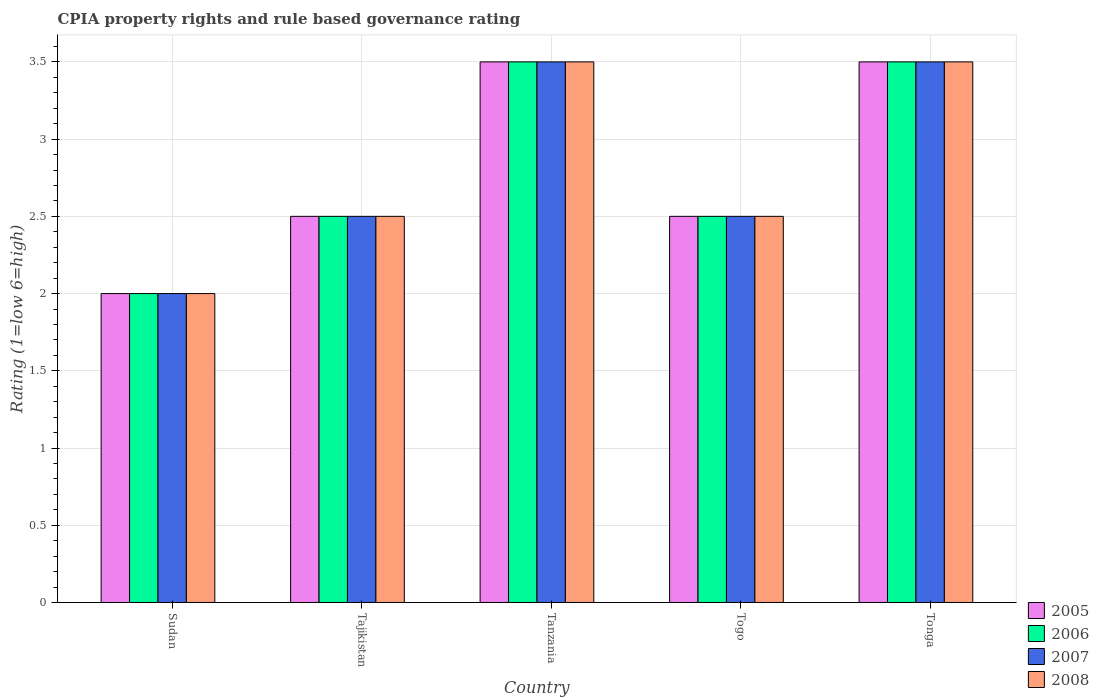Are the number of bars per tick equal to the number of legend labels?
Provide a short and direct response. Yes. Are the number of bars on each tick of the X-axis equal?
Ensure brevity in your answer.  Yes. How many bars are there on the 5th tick from the left?
Keep it short and to the point. 4. What is the label of the 5th group of bars from the left?
Your answer should be very brief. Tonga. Across all countries, what is the maximum CPIA rating in 2007?
Your answer should be very brief. 3.5. In which country was the CPIA rating in 2007 maximum?
Offer a terse response. Tanzania. In which country was the CPIA rating in 2008 minimum?
Provide a succinct answer. Sudan. What is the difference between the CPIA rating in 2006 in Togo and the CPIA rating in 2008 in Tanzania?
Your answer should be very brief. -1. What is the difference between the CPIA rating of/in 2007 and CPIA rating of/in 2008 in Tajikistan?
Provide a succinct answer. 0. In how many countries, is the CPIA rating in 2005 greater than 2.2?
Offer a terse response. 4. Is the CPIA rating in 2005 in Tajikistan less than that in Togo?
Your response must be concise. No. Is the difference between the CPIA rating in 2007 in Tanzania and Togo greater than the difference between the CPIA rating in 2008 in Tanzania and Togo?
Your answer should be very brief. No. What is the difference between the highest and the second highest CPIA rating in 2007?
Make the answer very short. -1. What is the difference between the highest and the lowest CPIA rating in 2007?
Your answer should be compact. 1.5. In how many countries, is the CPIA rating in 2007 greater than the average CPIA rating in 2007 taken over all countries?
Provide a short and direct response. 2. What does the 2nd bar from the left in Togo represents?
Make the answer very short. 2006. Is it the case that in every country, the sum of the CPIA rating in 2005 and CPIA rating in 2008 is greater than the CPIA rating in 2006?
Your answer should be very brief. Yes. How many bars are there?
Keep it short and to the point. 20. Are all the bars in the graph horizontal?
Your response must be concise. No. Are the values on the major ticks of Y-axis written in scientific E-notation?
Give a very brief answer. No. Does the graph contain any zero values?
Your answer should be compact. No. Does the graph contain grids?
Your answer should be compact. Yes. Where does the legend appear in the graph?
Your answer should be compact. Bottom right. How many legend labels are there?
Provide a succinct answer. 4. What is the title of the graph?
Your answer should be very brief. CPIA property rights and rule based governance rating. What is the label or title of the X-axis?
Your response must be concise. Country. What is the Rating (1=low 6=high) in 2008 in Sudan?
Provide a succinct answer. 2. What is the Rating (1=low 6=high) of 2005 in Tajikistan?
Offer a very short reply. 2.5. What is the Rating (1=low 6=high) of 2008 in Tajikistan?
Provide a short and direct response. 2.5. What is the Rating (1=low 6=high) in 2005 in Tanzania?
Your answer should be very brief. 3.5. What is the Rating (1=low 6=high) in 2006 in Tanzania?
Offer a terse response. 3.5. What is the Rating (1=low 6=high) in 2007 in Tanzania?
Offer a terse response. 3.5. What is the Rating (1=low 6=high) in 2008 in Tanzania?
Provide a succinct answer. 3.5. What is the Rating (1=low 6=high) in 2005 in Togo?
Your answer should be compact. 2.5. What is the Rating (1=low 6=high) in 2008 in Togo?
Your answer should be compact. 2.5. What is the Rating (1=low 6=high) in 2005 in Tonga?
Give a very brief answer. 3.5. What is the Rating (1=low 6=high) in 2006 in Tonga?
Make the answer very short. 3.5. What is the Rating (1=low 6=high) of 2007 in Tonga?
Give a very brief answer. 3.5. What is the Rating (1=low 6=high) in 2008 in Tonga?
Make the answer very short. 3.5. Across all countries, what is the maximum Rating (1=low 6=high) in 2006?
Make the answer very short. 3.5. Across all countries, what is the maximum Rating (1=low 6=high) of 2008?
Your answer should be very brief. 3.5. Across all countries, what is the minimum Rating (1=low 6=high) in 2006?
Provide a succinct answer. 2. Across all countries, what is the minimum Rating (1=low 6=high) in 2007?
Your answer should be very brief. 2. What is the total Rating (1=low 6=high) in 2007 in the graph?
Offer a very short reply. 14. What is the total Rating (1=low 6=high) in 2008 in the graph?
Provide a succinct answer. 14. What is the difference between the Rating (1=low 6=high) of 2005 in Sudan and that in Tajikistan?
Give a very brief answer. -0.5. What is the difference between the Rating (1=low 6=high) in 2007 in Sudan and that in Tajikistan?
Your response must be concise. -0.5. What is the difference between the Rating (1=low 6=high) of 2005 in Sudan and that in Tanzania?
Your answer should be compact. -1.5. What is the difference between the Rating (1=low 6=high) of 2007 in Sudan and that in Tanzania?
Provide a succinct answer. -1.5. What is the difference between the Rating (1=low 6=high) of 2008 in Sudan and that in Tanzania?
Provide a succinct answer. -1.5. What is the difference between the Rating (1=low 6=high) in 2005 in Sudan and that in Togo?
Offer a very short reply. -0.5. What is the difference between the Rating (1=low 6=high) in 2005 in Sudan and that in Tonga?
Keep it short and to the point. -1.5. What is the difference between the Rating (1=low 6=high) of 2006 in Sudan and that in Tonga?
Give a very brief answer. -1.5. What is the difference between the Rating (1=low 6=high) in 2007 in Sudan and that in Tonga?
Provide a succinct answer. -1.5. What is the difference between the Rating (1=low 6=high) in 2005 in Tajikistan and that in Tanzania?
Offer a terse response. -1. What is the difference between the Rating (1=low 6=high) of 2006 in Tajikistan and that in Tanzania?
Your response must be concise. -1. What is the difference between the Rating (1=low 6=high) in 2005 in Tajikistan and that in Togo?
Ensure brevity in your answer.  0. What is the difference between the Rating (1=low 6=high) of 2007 in Tajikistan and that in Togo?
Ensure brevity in your answer.  0. What is the difference between the Rating (1=low 6=high) of 2008 in Tajikistan and that in Togo?
Ensure brevity in your answer.  0. What is the difference between the Rating (1=low 6=high) of 2005 in Tajikistan and that in Tonga?
Offer a very short reply. -1. What is the difference between the Rating (1=low 6=high) of 2006 in Tajikistan and that in Tonga?
Offer a very short reply. -1. What is the difference between the Rating (1=low 6=high) of 2007 in Tajikistan and that in Tonga?
Offer a terse response. -1. What is the difference between the Rating (1=low 6=high) in 2008 in Tanzania and that in Togo?
Keep it short and to the point. 1. What is the difference between the Rating (1=low 6=high) in 2005 in Tanzania and that in Tonga?
Provide a short and direct response. 0. What is the difference between the Rating (1=low 6=high) in 2006 in Tanzania and that in Tonga?
Ensure brevity in your answer.  0. What is the difference between the Rating (1=low 6=high) of 2005 in Togo and that in Tonga?
Offer a very short reply. -1. What is the difference between the Rating (1=low 6=high) of 2008 in Togo and that in Tonga?
Ensure brevity in your answer.  -1. What is the difference between the Rating (1=low 6=high) of 2005 in Sudan and the Rating (1=low 6=high) of 2006 in Tajikistan?
Give a very brief answer. -0.5. What is the difference between the Rating (1=low 6=high) in 2005 in Sudan and the Rating (1=low 6=high) in 2007 in Tajikistan?
Your response must be concise. -0.5. What is the difference between the Rating (1=low 6=high) in 2005 in Sudan and the Rating (1=low 6=high) in 2008 in Tajikistan?
Make the answer very short. -0.5. What is the difference between the Rating (1=low 6=high) in 2006 in Sudan and the Rating (1=low 6=high) in 2007 in Tajikistan?
Your response must be concise. -0.5. What is the difference between the Rating (1=low 6=high) in 2005 in Sudan and the Rating (1=low 6=high) in 2007 in Tanzania?
Keep it short and to the point. -1.5. What is the difference between the Rating (1=low 6=high) in 2006 in Sudan and the Rating (1=low 6=high) in 2008 in Tanzania?
Provide a succinct answer. -1.5. What is the difference between the Rating (1=low 6=high) of 2007 in Sudan and the Rating (1=low 6=high) of 2008 in Tanzania?
Keep it short and to the point. -1.5. What is the difference between the Rating (1=low 6=high) of 2005 in Sudan and the Rating (1=low 6=high) of 2008 in Togo?
Provide a short and direct response. -0.5. What is the difference between the Rating (1=low 6=high) of 2006 in Sudan and the Rating (1=low 6=high) of 2007 in Togo?
Provide a succinct answer. -0.5. What is the difference between the Rating (1=low 6=high) in 2007 in Sudan and the Rating (1=low 6=high) in 2008 in Togo?
Your answer should be compact. -0.5. What is the difference between the Rating (1=low 6=high) of 2005 in Sudan and the Rating (1=low 6=high) of 2006 in Tonga?
Your answer should be compact. -1.5. What is the difference between the Rating (1=low 6=high) of 2005 in Sudan and the Rating (1=low 6=high) of 2007 in Tonga?
Offer a very short reply. -1.5. What is the difference between the Rating (1=low 6=high) in 2005 in Sudan and the Rating (1=low 6=high) in 2008 in Tonga?
Give a very brief answer. -1.5. What is the difference between the Rating (1=low 6=high) of 2006 in Sudan and the Rating (1=low 6=high) of 2008 in Tonga?
Provide a short and direct response. -1.5. What is the difference between the Rating (1=low 6=high) in 2007 in Sudan and the Rating (1=low 6=high) in 2008 in Tonga?
Your answer should be compact. -1.5. What is the difference between the Rating (1=low 6=high) in 2005 in Tajikistan and the Rating (1=low 6=high) in 2007 in Tanzania?
Offer a terse response. -1. What is the difference between the Rating (1=low 6=high) in 2006 in Tajikistan and the Rating (1=low 6=high) in 2008 in Tanzania?
Keep it short and to the point. -1. What is the difference between the Rating (1=low 6=high) of 2005 in Tajikistan and the Rating (1=low 6=high) of 2006 in Togo?
Offer a terse response. 0. What is the difference between the Rating (1=low 6=high) of 2005 in Tajikistan and the Rating (1=low 6=high) of 2007 in Togo?
Your answer should be very brief. 0. What is the difference between the Rating (1=low 6=high) of 2005 in Tajikistan and the Rating (1=low 6=high) of 2008 in Togo?
Provide a short and direct response. 0. What is the difference between the Rating (1=low 6=high) in 2006 in Tajikistan and the Rating (1=low 6=high) in 2008 in Togo?
Make the answer very short. 0. What is the difference between the Rating (1=low 6=high) of 2007 in Tajikistan and the Rating (1=low 6=high) of 2008 in Togo?
Offer a terse response. 0. What is the difference between the Rating (1=low 6=high) of 2005 in Tajikistan and the Rating (1=low 6=high) of 2006 in Tonga?
Ensure brevity in your answer.  -1. What is the difference between the Rating (1=low 6=high) of 2005 in Tajikistan and the Rating (1=low 6=high) of 2007 in Tonga?
Offer a terse response. -1. What is the difference between the Rating (1=low 6=high) in 2006 in Tajikistan and the Rating (1=low 6=high) in 2008 in Tonga?
Your answer should be very brief. -1. What is the difference between the Rating (1=low 6=high) in 2007 in Tajikistan and the Rating (1=low 6=high) in 2008 in Tonga?
Provide a short and direct response. -1. What is the difference between the Rating (1=low 6=high) in 2005 in Tanzania and the Rating (1=low 6=high) in 2007 in Togo?
Give a very brief answer. 1. What is the difference between the Rating (1=low 6=high) of 2005 in Tanzania and the Rating (1=low 6=high) of 2008 in Togo?
Make the answer very short. 1. What is the difference between the Rating (1=low 6=high) of 2007 in Tanzania and the Rating (1=low 6=high) of 2008 in Togo?
Offer a very short reply. 1. What is the difference between the Rating (1=low 6=high) of 2005 in Tanzania and the Rating (1=low 6=high) of 2006 in Tonga?
Offer a terse response. 0. What is the difference between the Rating (1=low 6=high) in 2005 in Tanzania and the Rating (1=low 6=high) in 2007 in Tonga?
Provide a succinct answer. 0. What is the difference between the Rating (1=low 6=high) of 2005 in Togo and the Rating (1=low 6=high) of 2008 in Tonga?
Make the answer very short. -1. What is the difference between the Rating (1=low 6=high) of 2006 in Togo and the Rating (1=low 6=high) of 2007 in Tonga?
Your answer should be compact. -1. What is the difference between the Rating (1=low 6=high) in 2006 in Togo and the Rating (1=low 6=high) in 2008 in Tonga?
Keep it short and to the point. -1. What is the average Rating (1=low 6=high) in 2005 per country?
Offer a terse response. 2.8. What is the average Rating (1=low 6=high) in 2006 per country?
Give a very brief answer. 2.8. What is the average Rating (1=low 6=high) of 2008 per country?
Offer a terse response. 2.8. What is the difference between the Rating (1=low 6=high) in 2005 and Rating (1=low 6=high) in 2006 in Sudan?
Offer a terse response. 0. What is the difference between the Rating (1=low 6=high) of 2005 and Rating (1=low 6=high) of 2007 in Sudan?
Make the answer very short. 0. What is the difference between the Rating (1=low 6=high) in 2005 and Rating (1=low 6=high) in 2008 in Sudan?
Ensure brevity in your answer.  0. What is the difference between the Rating (1=low 6=high) of 2006 and Rating (1=low 6=high) of 2007 in Sudan?
Provide a short and direct response. 0. What is the difference between the Rating (1=low 6=high) of 2007 and Rating (1=low 6=high) of 2008 in Sudan?
Provide a short and direct response. 0. What is the difference between the Rating (1=low 6=high) in 2005 and Rating (1=low 6=high) in 2007 in Tajikistan?
Your response must be concise. 0. What is the difference between the Rating (1=low 6=high) in 2006 and Rating (1=low 6=high) in 2007 in Tajikistan?
Make the answer very short. 0. What is the difference between the Rating (1=low 6=high) in 2006 and Rating (1=low 6=high) in 2008 in Tajikistan?
Make the answer very short. 0. What is the difference between the Rating (1=low 6=high) of 2005 and Rating (1=low 6=high) of 2006 in Tanzania?
Keep it short and to the point. 0. What is the difference between the Rating (1=low 6=high) in 2005 and Rating (1=low 6=high) in 2007 in Tanzania?
Your answer should be very brief. 0. What is the difference between the Rating (1=low 6=high) of 2005 and Rating (1=low 6=high) of 2008 in Tanzania?
Your response must be concise. 0. What is the difference between the Rating (1=low 6=high) of 2006 and Rating (1=low 6=high) of 2007 in Tanzania?
Offer a terse response. 0. What is the difference between the Rating (1=low 6=high) in 2007 and Rating (1=low 6=high) in 2008 in Tanzania?
Provide a short and direct response. 0. What is the difference between the Rating (1=low 6=high) of 2005 and Rating (1=low 6=high) of 2006 in Togo?
Your answer should be very brief. 0. What is the difference between the Rating (1=low 6=high) of 2006 and Rating (1=low 6=high) of 2007 in Togo?
Provide a succinct answer. 0. What is the difference between the Rating (1=low 6=high) in 2006 and Rating (1=low 6=high) in 2008 in Togo?
Provide a short and direct response. 0. What is the difference between the Rating (1=low 6=high) in 2007 and Rating (1=low 6=high) in 2008 in Togo?
Offer a terse response. 0. What is the difference between the Rating (1=low 6=high) in 2005 and Rating (1=low 6=high) in 2006 in Tonga?
Provide a short and direct response. 0. What is the difference between the Rating (1=low 6=high) in 2005 and Rating (1=low 6=high) in 2007 in Tonga?
Provide a short and direct response. 0. What is the difference between the Rating (1=low 6=high) of 2005 and Rating (1=low 6=high) of 2008 in Tonga?
Provide a succinct answer. 0. What is the difference between the Rating (1=low 6=high) in 2006 and Rating (1=low 6=high) in 2008 in Tonga?
Offer a very short reply. 0. What is the difference between the Rating (1=low 6=high) in 2007 and Rating (1=low 6=high) in 2008 in Tonga?
Your response must be concise. 0. What is the ratio of the Rating (1=low 6=high) of 2005 in Sudan to that in Tajikistan?
Make the answer very short. 0.8. What is the ratio of the Rating (1=low 6=high) in 2006 in Sudan to that in Tajikistan?
Give a very brief answer. 0.8. What is the ratio of the Rating (1=low 6=high) in 2007 in Sudan to that in Tajikistan?
Provide a succinct answer. 0.8. What is the ratio of the Rating (1=low 6=high) of 2006 in Sudan to that in Tanzania?
Your response must be concise. 0.57. What is the ratio of the Rating (1=low 6=high) of 2007 in Sudan to that in Tanzania?
Provide a short and direct response. 0.57. What is the ratio of the Rating (1=low 6=high) in 2005 in Sudan to that in Togo?
Your response must be concise. 0.8. What is the ratio of the Rating (1=low 6=high) in 2006 in Sudan to that in Togo?
Your response must be concise. 0.8. What is the ratio of the Rating (1=low 6=high) of 2008 in Sudan to that in Togo?
Offer a very short reply. 0.8. What is the ratio of the Rating (1=low 6=high) in 2006 in Sudan to that in Tonga?
Offer a very short reply. 0.57. What is the ratio of the Rating (1=low 6=high) of 2008 in Sudan to that in Tonga?
Provide a succinct answer. 0.57. What is the ratio of the Rating (1=low 6=high) in 2007 in Tajikistan to that in Togo?
Offer a terse response. 1. What is the ratio of the Rating (1=low 6=high) of 2005 in Tajikistan to that in Tonga?
Provide a short and direct response. 0.71. What is the ratio of the Rating (1=low 6=high) in 2006 in Tajikistan to that in Tonga?
Offer a very short reply. 0.71. What is the ratio of the Rating (1=low 6=high) of 2007 in Tajikistan to that in Tonga?
Provide a short and direct response. 0.71. What is the ratio of the Rating (1=low 6=high) in 2006 in Tanzania to that in Tonga?
Give a very brief answer. 1. What is the ratio of the Rating (1=low 6=high) of 2007 in Togo to that in Tonga?
Give a very brief answer. 0.71. What is the ratio of the Rating (1=low 6=high) of 2008 in Togo to that in Tonga?
Keep it short and to the point. 0.71. What is the difference between the highest and the second highest Rating (1=low 6=high) in 2006?
Offer a very short reply. 0. What is the difference between the highest and the second highest Rating (1=low 6=high) in 2008?
Give a very brief answer. 0. What is the difference between the highest and the lowest Rating (1=low 6=high) of 2005?
Provide a succinct answer. 1.5. What is the difference between the highest and the lowest Rating (1=low 6=high) in 2008?
Your answer should be compact. 1.5. 